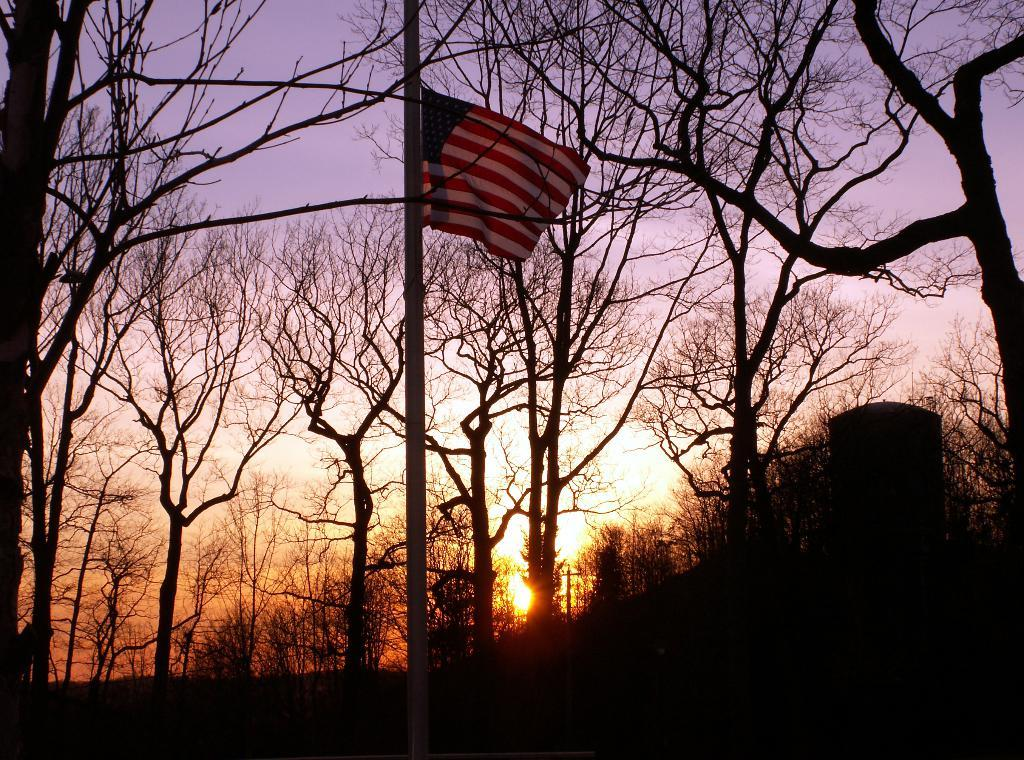What is the setting of the image? The image is an outside view. What can be seen on the pole in the image? A flag is attached to the pole in the image. What is visible in the background of the image? There are trees in the background of the image. What is the condition of the sky in the image? The sun is visible in the sky in the image. What type of friction can be observed between the flag and the pole in the image? There is no friction between the flag and the pole in the image; the flag is simply attached to the pole. What fact is being represented by the flag in the image? The image does not provide any information about the meaning or symbolism of the flag, so it is impossible to determine what fact it represents. 